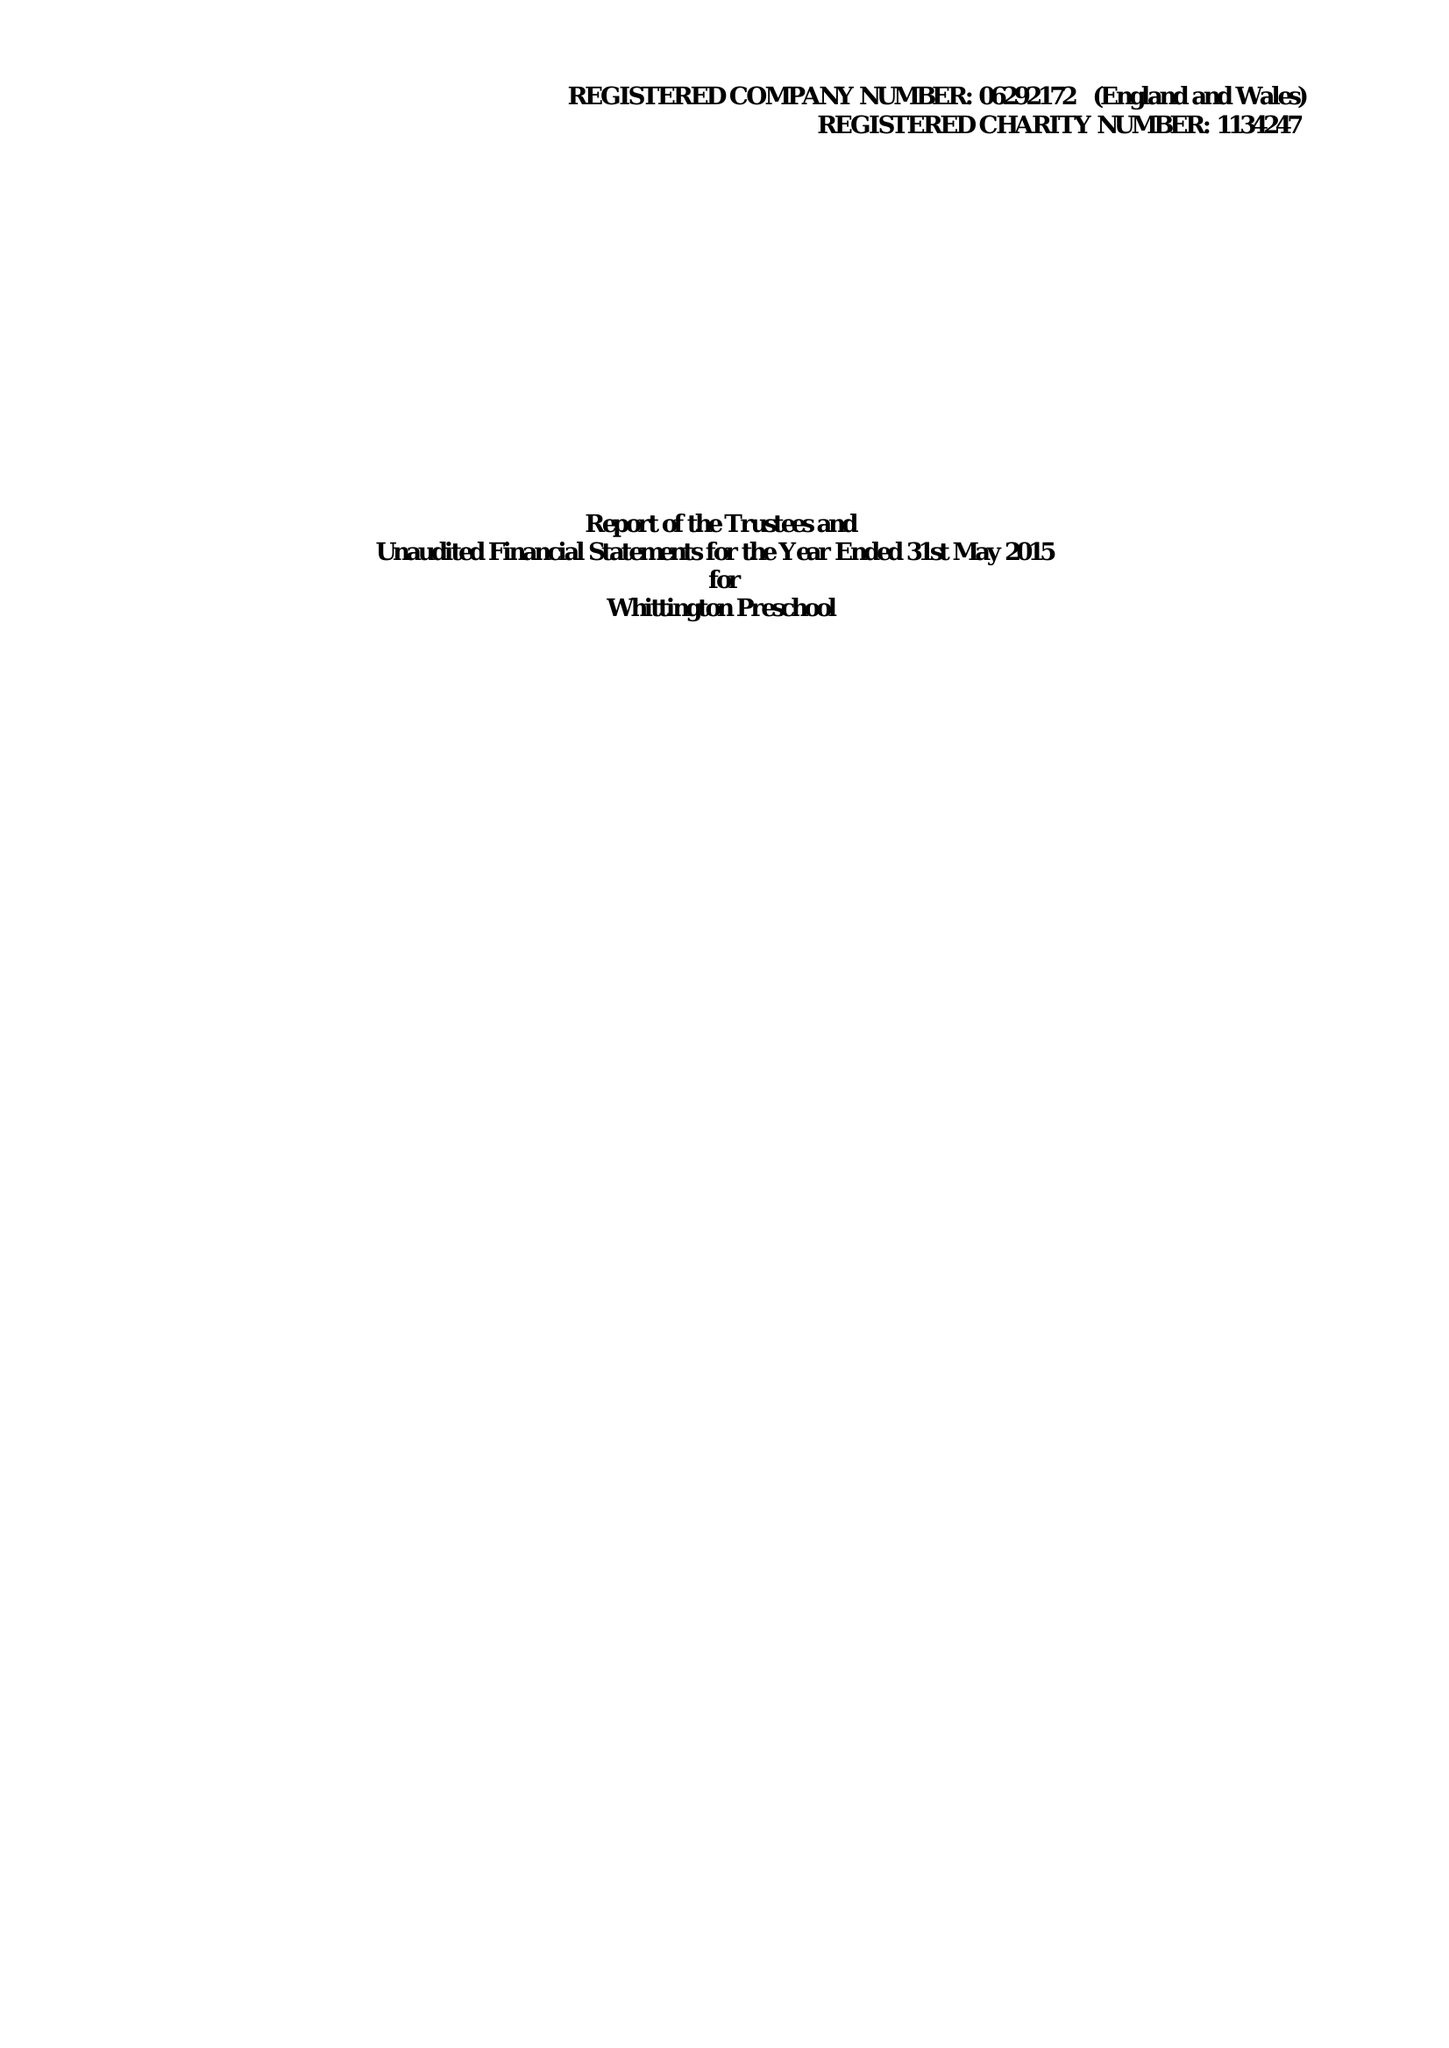What is the value for the charity_name?
Answer the question using a single word or phrase. Whittington Preschool 